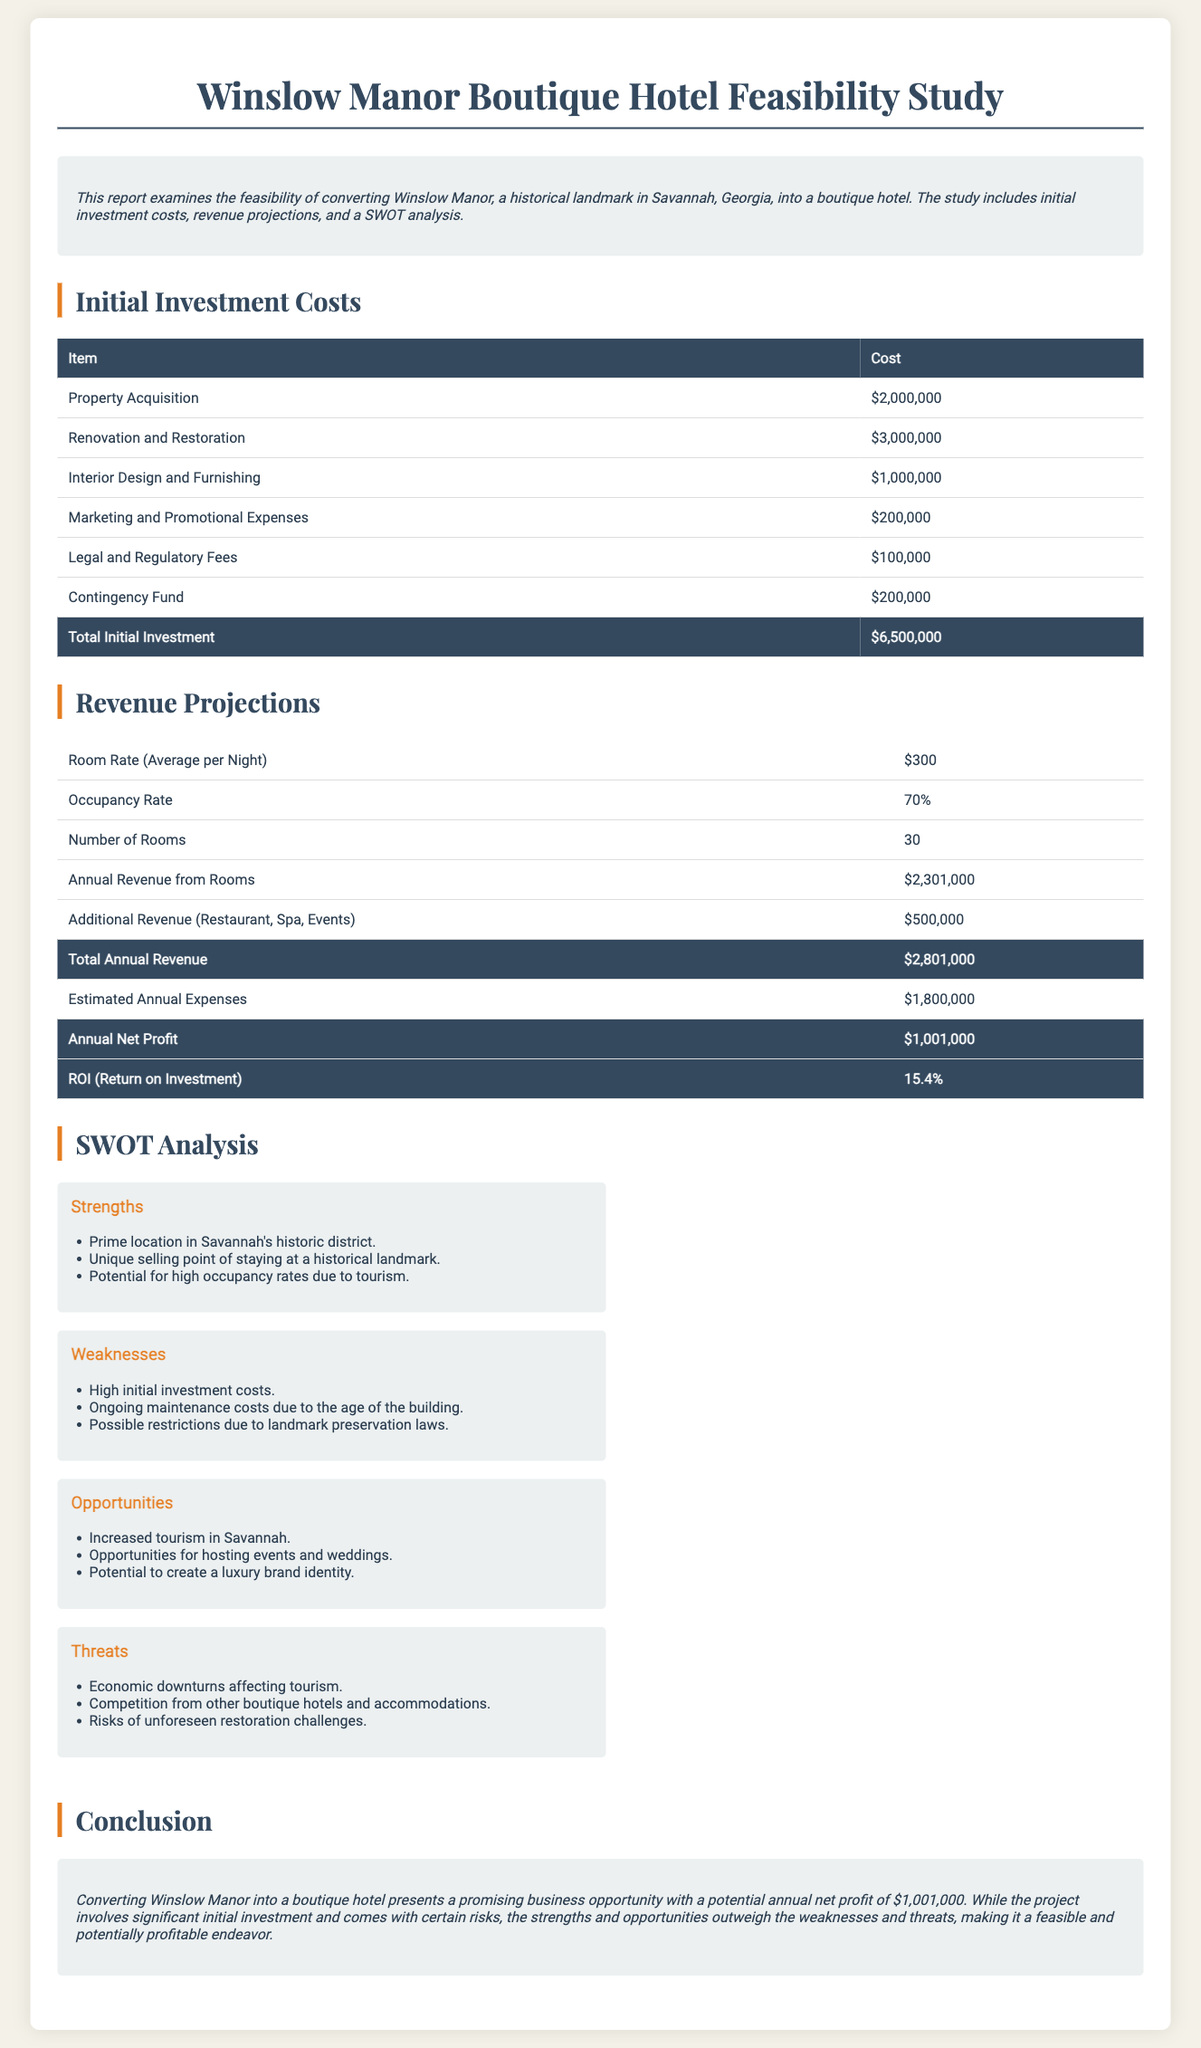What is the property acquisition cost? The property acquisition cost is specified in the initial investment costs section, listed as $2,000,000.
Answer: $2,000,000 What is the estimated annual profit? The estimated annual profit is found under the revenue projections, calculated as total annual revenue minus estimated annual expenses.
Answer: $1,001,000 What is the average room rate per night? The average room rate per night is provided in the revenue projections section and is stated as $300.
Answer: $300 What are the strengths mentioned in the SWOT analysis? The strengths can be found in the SWOT analysis section, which mentions factors like location, unique selling point, and tourism potential.
Answer: Prime location in Savannah's historic district; Unique selling point of staying at a historical landmark; Potential for high occupancy rates due to tourism What is the total initial investment? The total initial investment is listed at the end of the initial investment costs table, summarizing all expenses.
Answer: $6,500,000 What is the annual return on investment (ROI)? The annual return on investment is calculated in the revenue projections section and is provided as a percentage.
Answer: 15.4% What is the total annual revenue? The total annual revenue is the sum of annual revenue from rooms and additional revenue as outlined in the revenue projections.
Answer: $2,801,000 What potential threat is identified in the SWOT analysis? The threats in the SWOT analysis include various risks, specifically those related to economic downturns and competition.
Answer: Economic downturns affecting tourism 